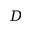Convert formula to latex. <formula><loc_0><loc_0><loc_500><loc_500>D</formula> 